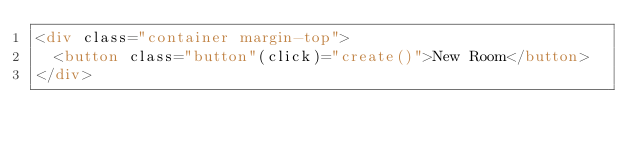<code> <loc_0><loc_0><loc_500><loc_500><_HTML_><div class="container margin-top">
  <button class="button"(click)="create()">New Room</button>
</div></code> 